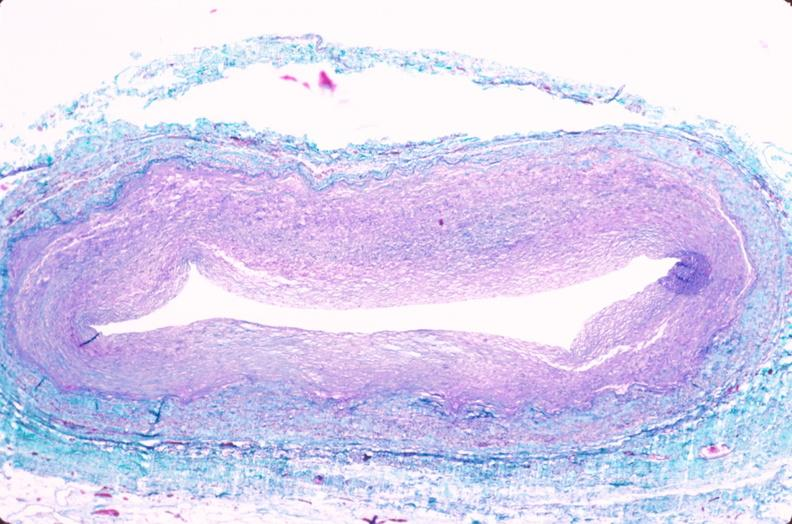s macerated stillborn present?
Answer the question using a single word or phrase. No 